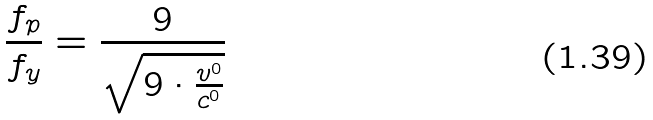Convert formula to latex. <formula><loc_0><loc_0><loc_500><loc_500>\frac { f _ { p } } { f _ { y } } = \frac { 9 } { \sqrt { 9 \cdot \frac { v ^ { 0 } } { c ^ { 0 } } } }</formula> 